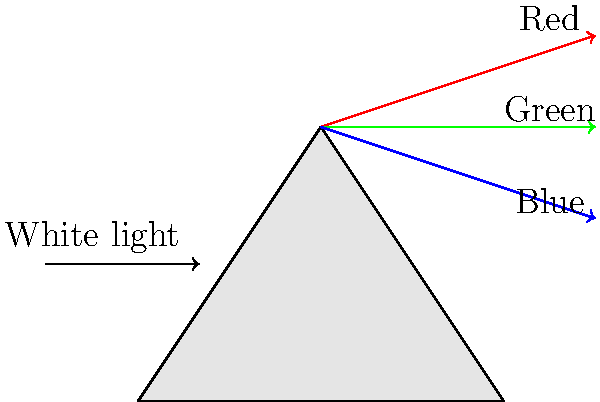How does the refraction of light through a prism, as shown in the diagram, relate to the color separation techniques used by Renaissance painters in their artworks? Consider the physical principles involved and their artistic applications. 1. Light refraction in a prism:
   - White light enters the prism and is refracted.
   - Different wavelengths (colors) of light bend at different angles.
   - This results in the separation of white light into its component colors.

2. Color theory in Renaissance painting:
   - Renaissance artists didn't have prisms, but understood color separation.
   - They used techniques like glazing and layering to create depth and luminosity.

3. Similarities in principles:
   - Both rely on the properties of light and color.
   - In prisms, colors separate due to different refractive indices.
   - In paintings, artists layered translucent colors to create optical mixing.

4. Artistic application:
   - Renaissance painters used this understanding to create more realistic and vibrant artworks.
   - They could simulate the effects of light passing through different mediums, similar to a prism.

5. Examples in Renaissance art:
   - Leonardo da Vinci's sfumato technique created soft, prism-like color transitions.
   - Titian's use of glazes produced luminous effects reminiscent of light dispersion.

6. Modern connections:
   - Understanding of light refraction influences both scientific and artistic fields.
   - Contemporary artists often incorporate scientific principles of light and color in their work.
Answer: Both prism refraction and Renaissance color techniques exploit light properties to separate and manipulate colors, achieving visual depth and luminosity. 